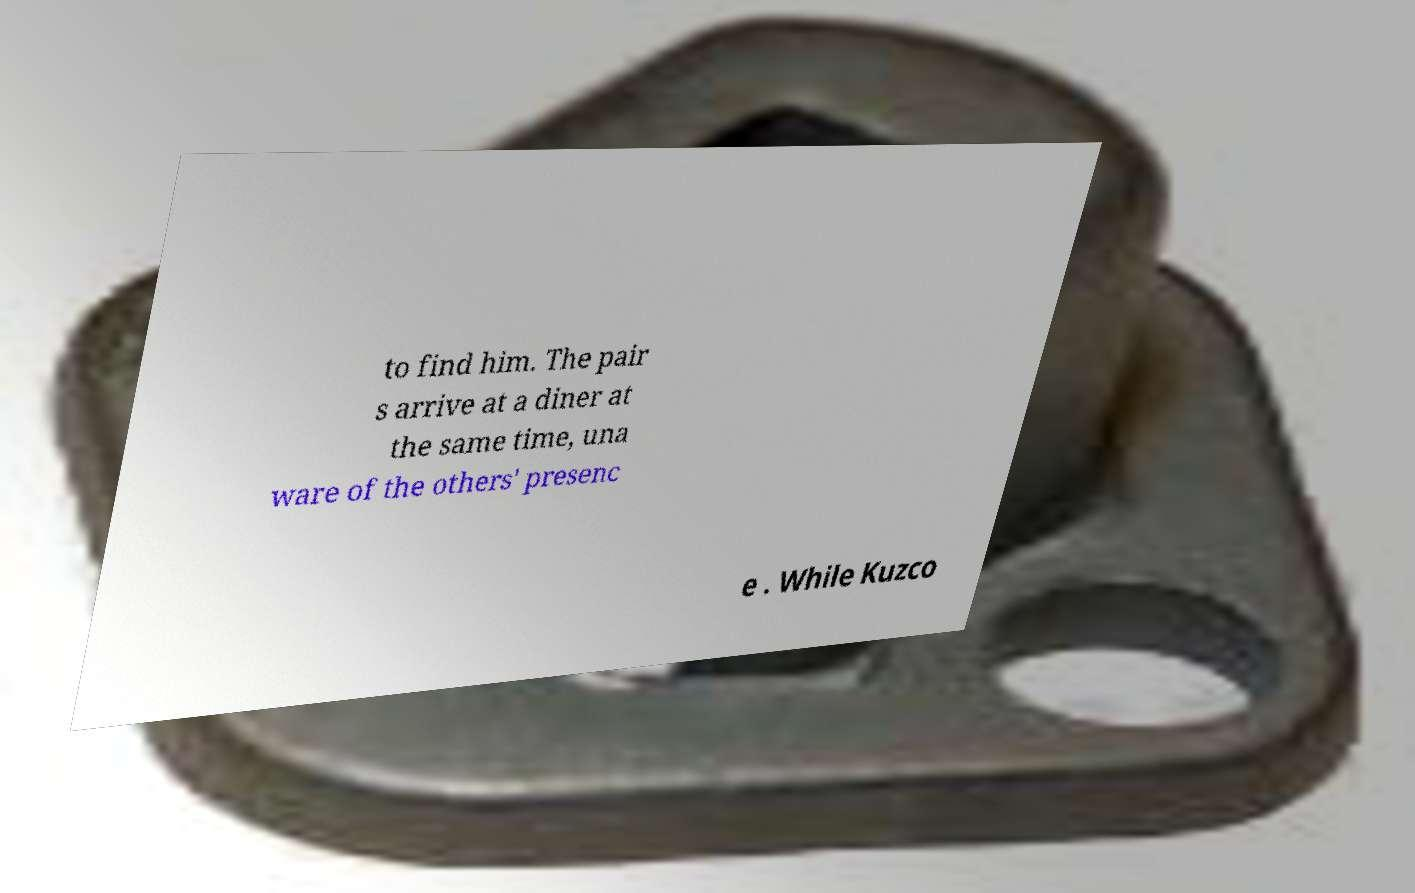Could you assist in decoding the text presented in this image and type it out clearly? to find him. The pair s arrive at a diner at the same time, una ware of the others' presenc e . While Kuzco 